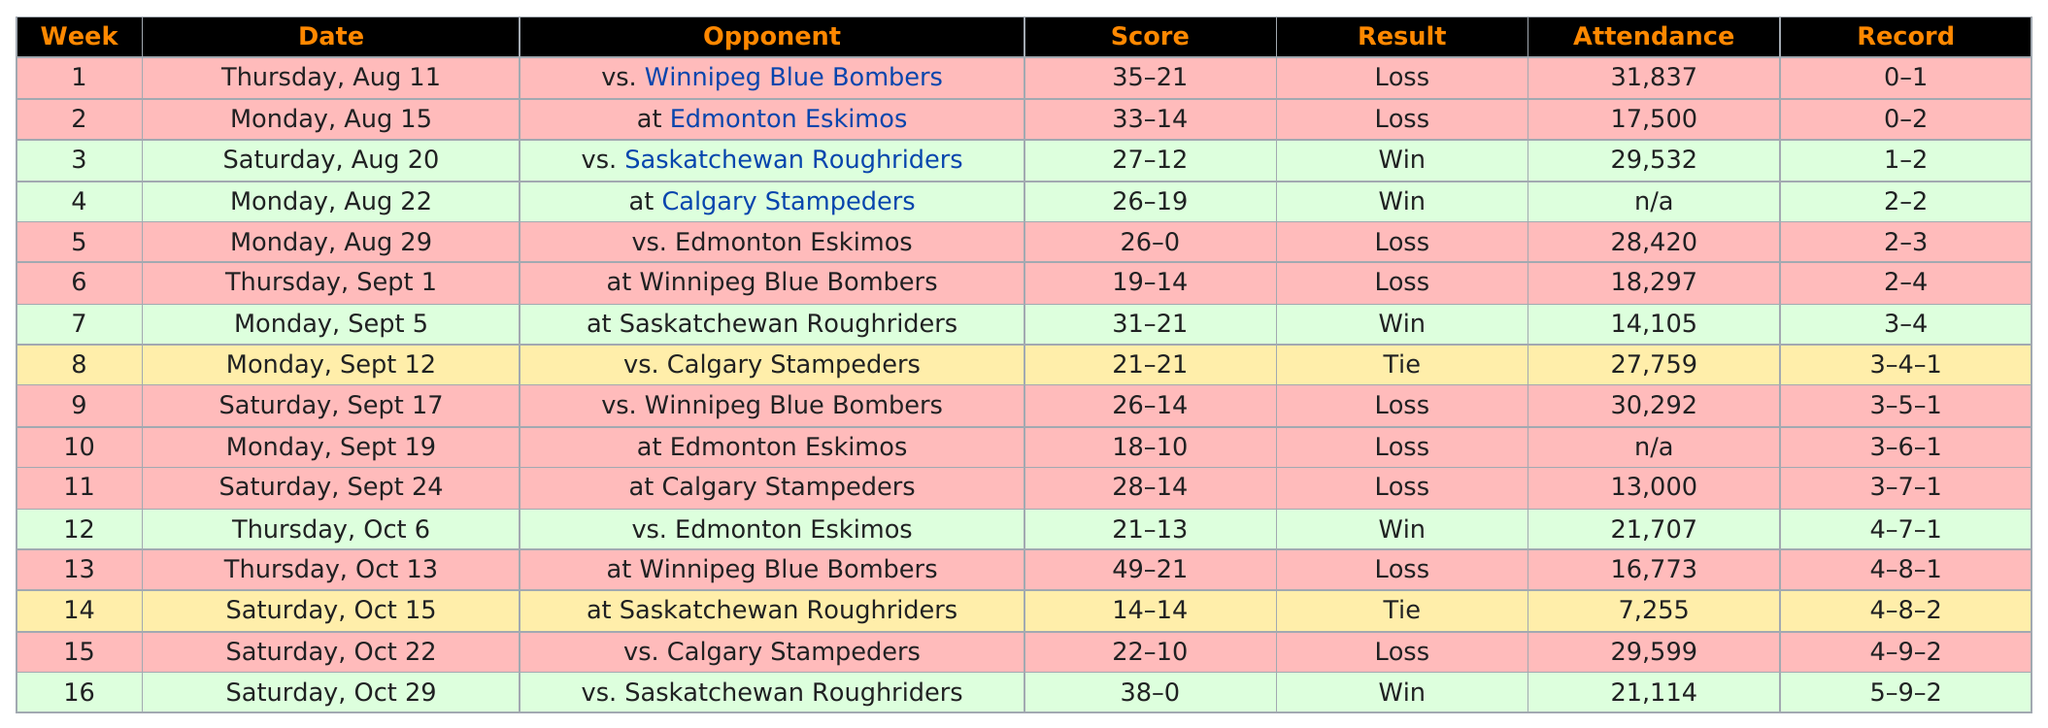Mention a couple of crucial points in this snapshot. Out of the total number of games played, the outcome resulted in a loss on 9 occasions. The number of games won and the number of games lost differ by 4. In total, 5 games were won. According to the provided information, 21,707 people attended the first game that the team won in October. The total number of wins for this team in the preseason was 2. 